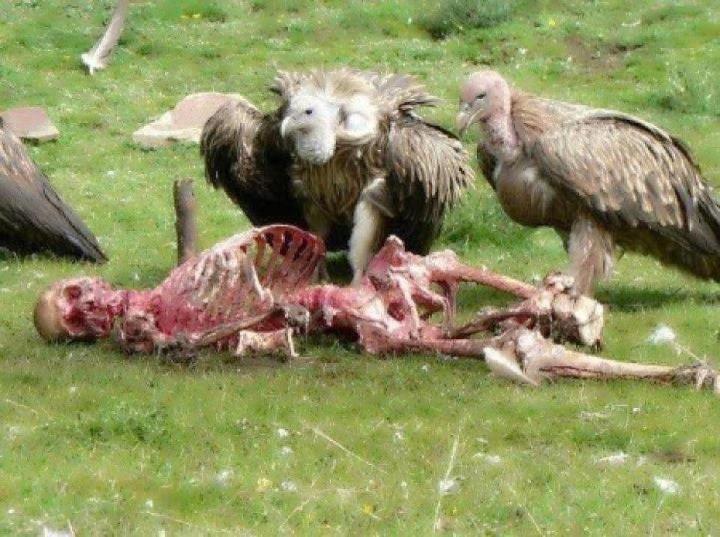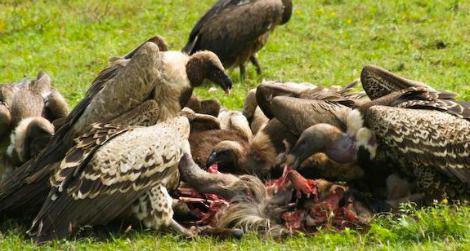The first image is the image on the left, the second image is the image on the right. Examine the images to the left and right. Is the description "The right image contains no more than one large bird." accurate? Answer yes or no. No. The first image is the image on the left, the second image is the image on the right. For the images shown, is this caption "An image contains only one live vulture, which is standing next to some type of carcass, but not on top of it." true? Answer yes or no. No. 